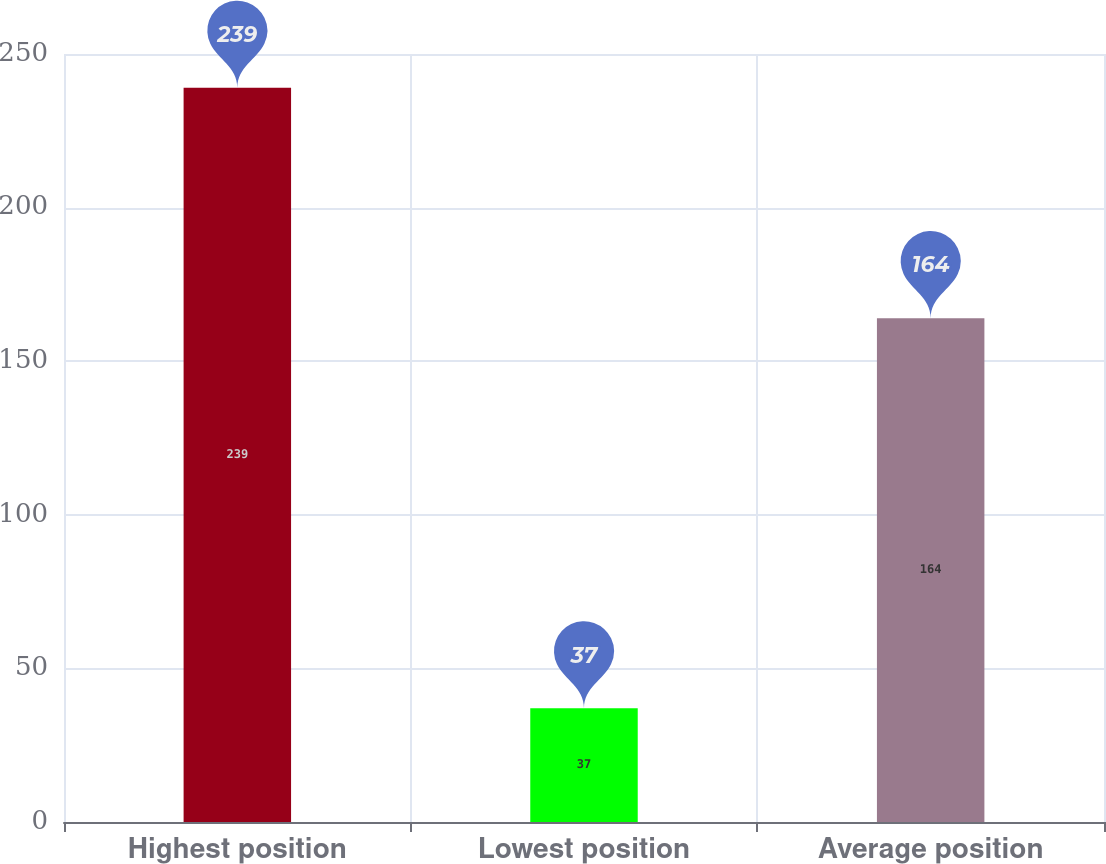Convert chart to OTSL. <chart><loc_0><loc_0><loc_500><loc_500><bar_chart><fcel>Highest position<fcel>Lowest position<fcel>Average position<nl><fcel>239<fcel>37<fcel>164<nl></chart> 